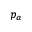Convert formula to latex. <formula><loc_0><loc_0><loc_500><loc_500>p _ { \alpha }</formula> 